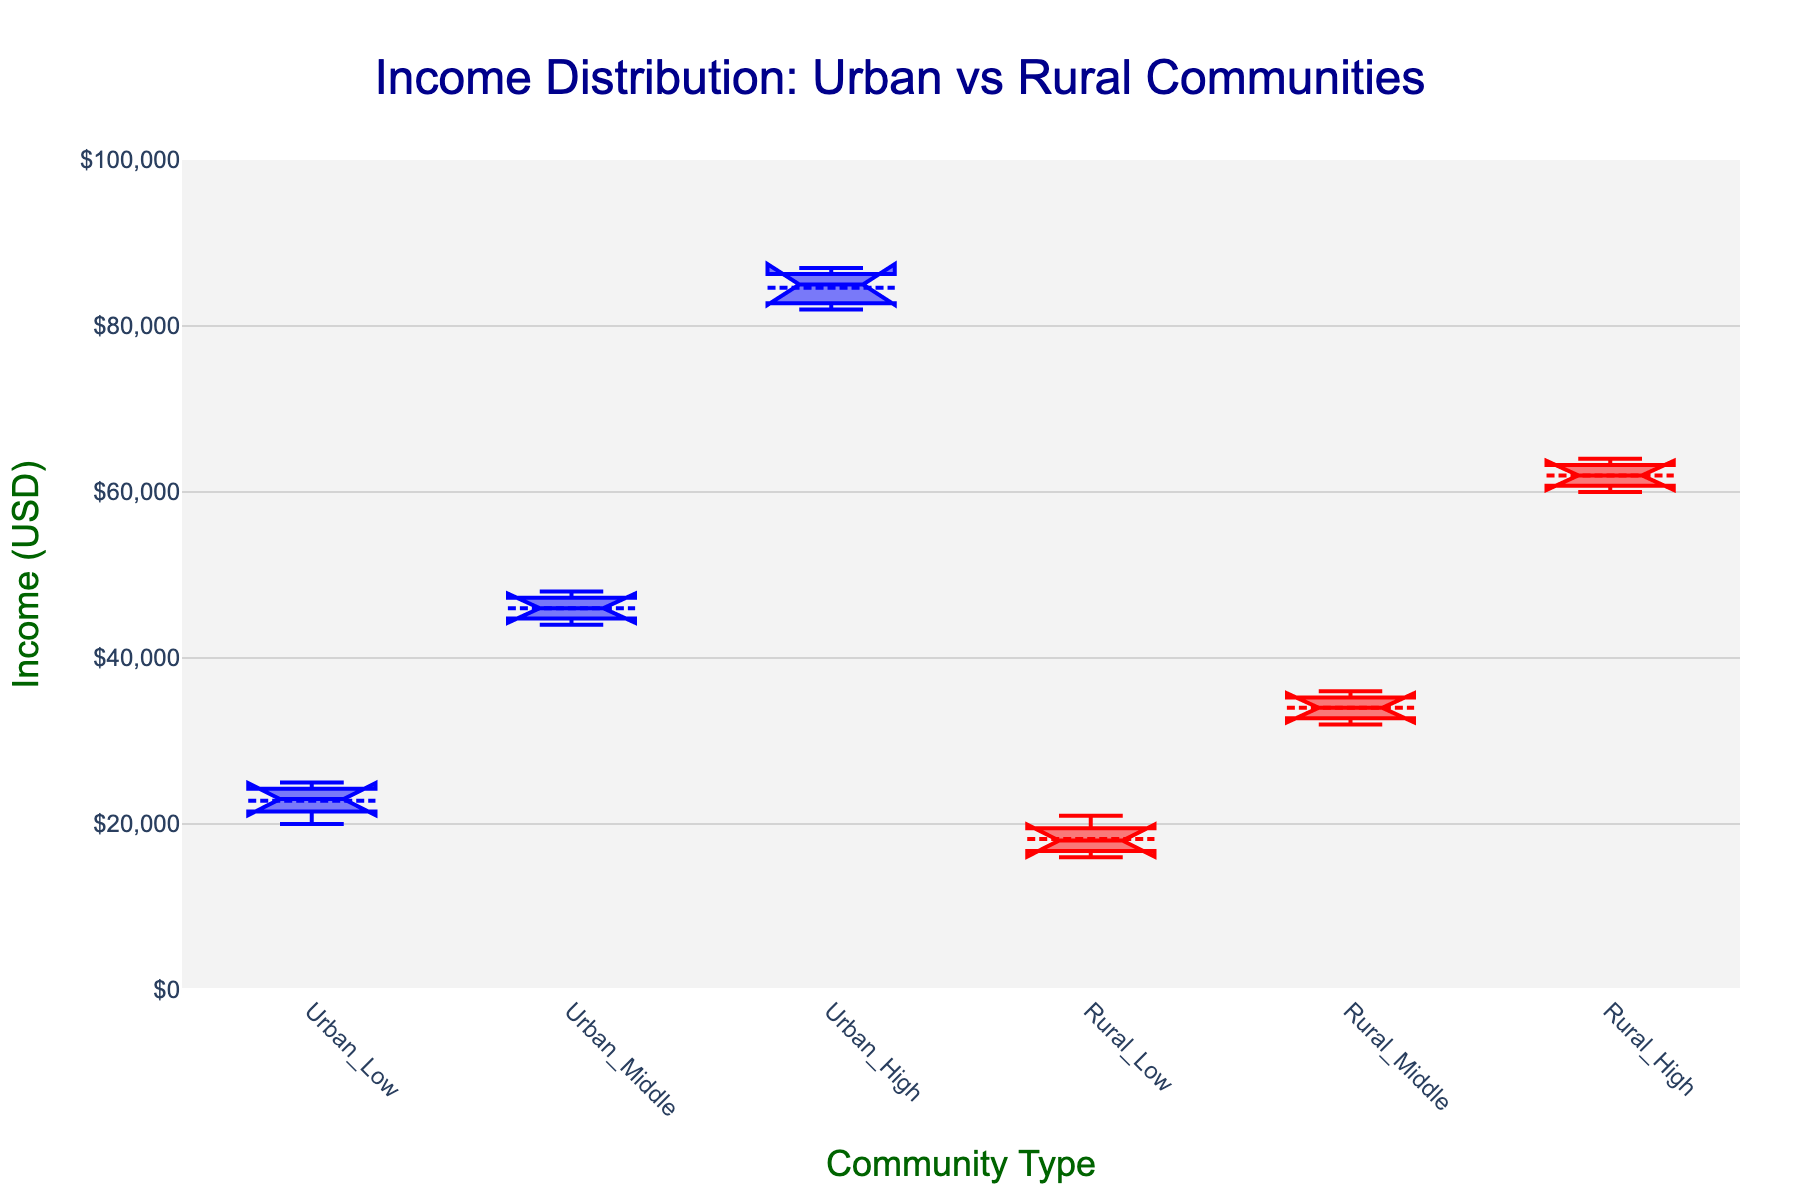What is the title of the figure? The title of the figure is clearly visible at the top of the plot and reads "Income Distribution: Urban vs Rural Communities."
Answer: Income Distribution: Urban vs Rural Communities Which community type shows the highest median income level among the high-income groups? Look at the median lines within the notched sections of the high-income groups. The Urban_High group has a higher median compared to the Rural_High group.
Answer: Urban_High What is the range of income values displayed on the y-axis? The y-axis range limits can be identified by looking at the bottom and top of the y-axis. The y-axis ranges from 0 to 100,000 USD.
Answer: 0 to 100,000 USD How does the width of the notches compare between Urban_Low and Rural_Low groups? The width of the notches indicates the uncertainty in the estimate of the median value. Compare the width of the notches in the Urban_Low and Rural_Low groups to see which is narrower.
Answer: Rural_Low is narrower Which group has the most dispersed income distribution among middle-income levels? The dispersion of the data in each group can be identified by looking at the height of the boxes. The larger the interquartile range (IQR), the more dispersed the data.
Answer: Urban_Middle Are the mean incomes for the Urban_High and Rural_High groups similar? The mean of each group is indicated by the line or marker within the box. Compare the position of these mean markers for the Urban_High and Rural_High groups.
Answer: No What's the difference between the median income of Urban_Low and Rural_Low groups? Identify the median (central line within the notch) for both Urban_Low and Rural_Low groups, then calculate their difference. Suppose Urban_Low is 23000 and Rural_Low is 18000: 23000 - 18000 = 5000.
Answer: 5000 Which community type has the lowest interquartile range for the middle-income group? Interquartile Range (IQR) is the height of the box from the first quartile (lower boundary) to the third quartile (upper boundary). Compare the IQRs of the middle-income groups.
Answer: Rural_Middle Among the low-income levels, which community has a higher outlier income point? Outliers are represented as points outside the whiskers of the box plot. Compare these points in the Urban_Low and Rural_Low groups.
Answer: Urban_Low How does income variability in the high-income group of Urban compare to that of Rural? Income variability can be assessed by the height of the boxes and the range of whiskers. Compare these features in the Urban_High and Rural_High groups to determine variability.
Answer: Greater in Urban 